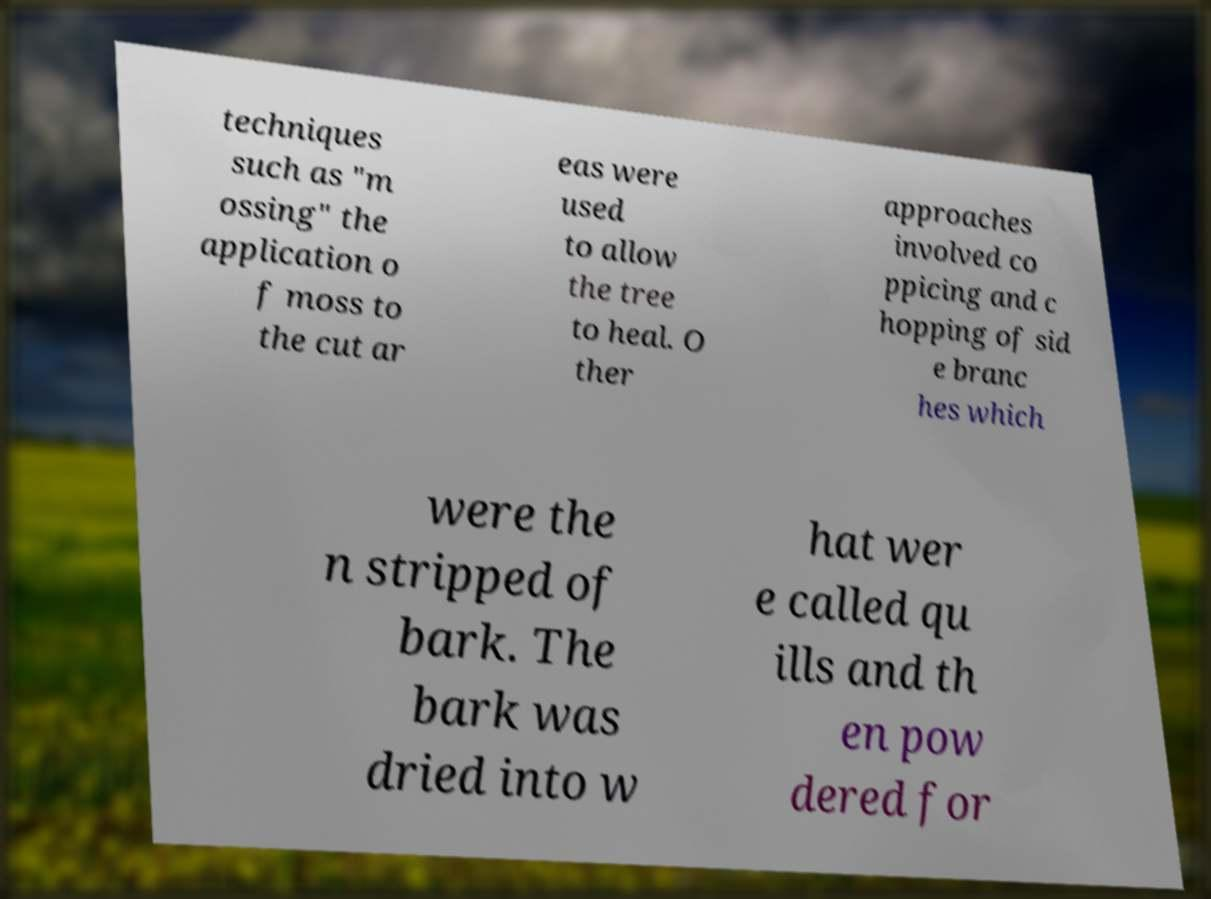Could you extract and type out the text from this image? techniques such as "m ossing" the application o f moss to the cut ar eas were used to allow the tree to heal. O ther approaches involved co ppicing and c hopping of sid e branc hes which were the n stripped of bark. The bark was dried into w hat wer e called qu ills and th en pow dered for 